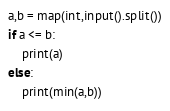<code> <loc_0><loc_0><loc_500><loc_500><_Python_>a,b = map(int,input().split())
if a <= b:
    print(a)
else:
    print(min(a,b))</code> 